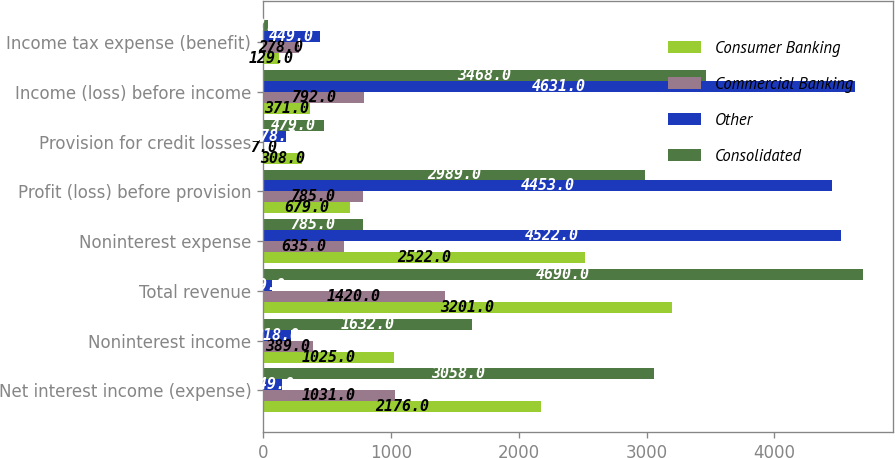Convert chart. <chart><loc_0><loc_0><loc_500><loc_500><stacked_bar_chart><ecel><fcel>Net interest income (expense)<fcel>Noninterest income<fcel>Total revenue<fcel>Noninterest expense<fcel>Profit (loss) before provision<fcel>Provision for credit losses<fcel>Income (loss) before income<fcel>Income tax expense (benefit)<nl><fcel>Consumer Banking<fcel>2176<fcel>1025<fcel>3201<fcel>2522<fcel>679<fcel>308<fcel>371<fcel>129<nl><fcel>Commercial Banking<fcel>1031<fcel>389<fcel>1420<fcel>635<fcel>785<fcel>7<fcel>792<fcel>278<nl><fcel>Other<fcel>149<fcel>218<fcel>69<fcel>4522<fcel>4453<fcel>178<fcel>4631<fcel>449<nl><fcel>Consolidated<fcel>3058<fcel>1632<fcel>4690<fcel>785<fcel>2989<fcel>479<fcel>3468<fcel>42<nl></chart> 